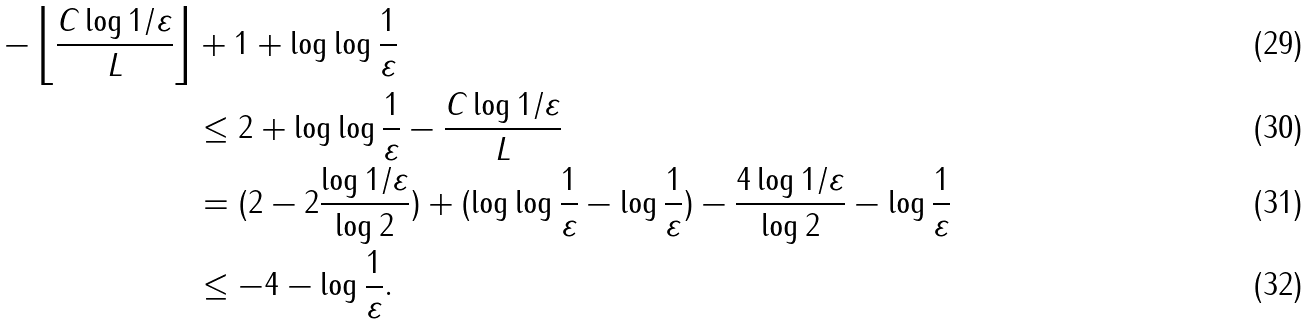Convert formula to latex. <formula><loc_0><loc_0><loc_500><loc_500>- \left \lfloor \frac { C \log 1 / \varepsilon } { L } \right \rfloor & + 1 + \log \log \frac { 1 } { \varepsilon } \\ & \leq 2 + \log \log \frac { 1 } { \varepsilon } - \frac { C \log 1 / \varepsilon } { L } \\ & = ( 2 - 2 \frac { \log 1 / \varepsilon } { \log 2 } ) + ( \log \log \frac { 1 } { \varepsilon } - \log \frac { 1 } { \varepsilon } ) - \frac { 4 \log 1 / \varepsilon } { \log 2 } - \log \frac { 1 } { \varepsilon } \\ & \leq - 4 - \log \frac { 1 } { \varepsilon } .</formula> 